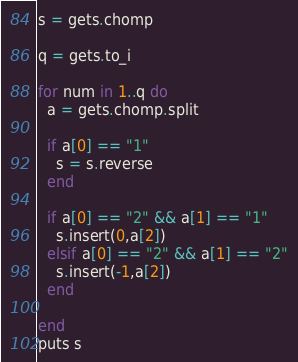<code> <loc_0><loc_0><loc_500><loc_500><_Ruby_>s = gets.chomp

q = gets.to_i

for num in 1..q do
  a = gets.chomp.split
  
  if a[0] == "1"
    s = s.reverse
  end
    
  if a[0] == "2" && a[1] == "1"
    s.insert(0,a[2])
  elsif a[0] == "2" && a[1] == "2"
    s.insert(-1,a[2])
  end
  
end
puts s</code> 